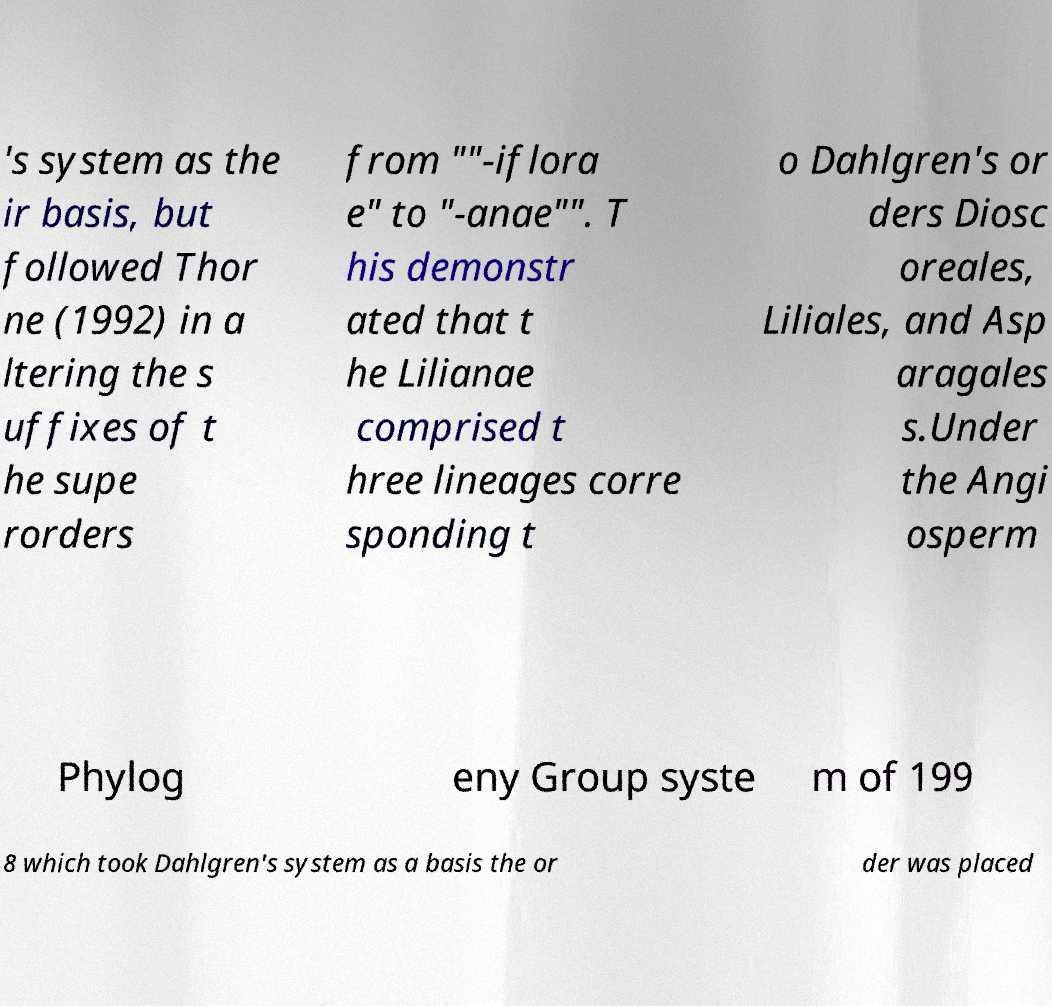I need the written content from this picture converted into text. Can you do that? 's system as the ir basis, but followed Thor ne (1992) in a ltering the s uffixes of t he supe rorders from ""-iflora e" to "-anae"". T his demonstr ated that t he Lilianae comprised t hree lineages corre sponding t o Dahlgren's or ders Diosc oreales, Liliales, and Asp aragales s.Under the Angi osperm Phylog eny Group syste m of 199 8 which took Dahlgren's system as a basis the or der was placed 